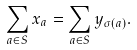Convert formula to latex. <formula><loc_0><loc_0><loc_500><loc_500>\sum _ { a \in S } x _ { a } = \sum _ { a \in S } y _ { \sigma ( a ) } .</formula> 